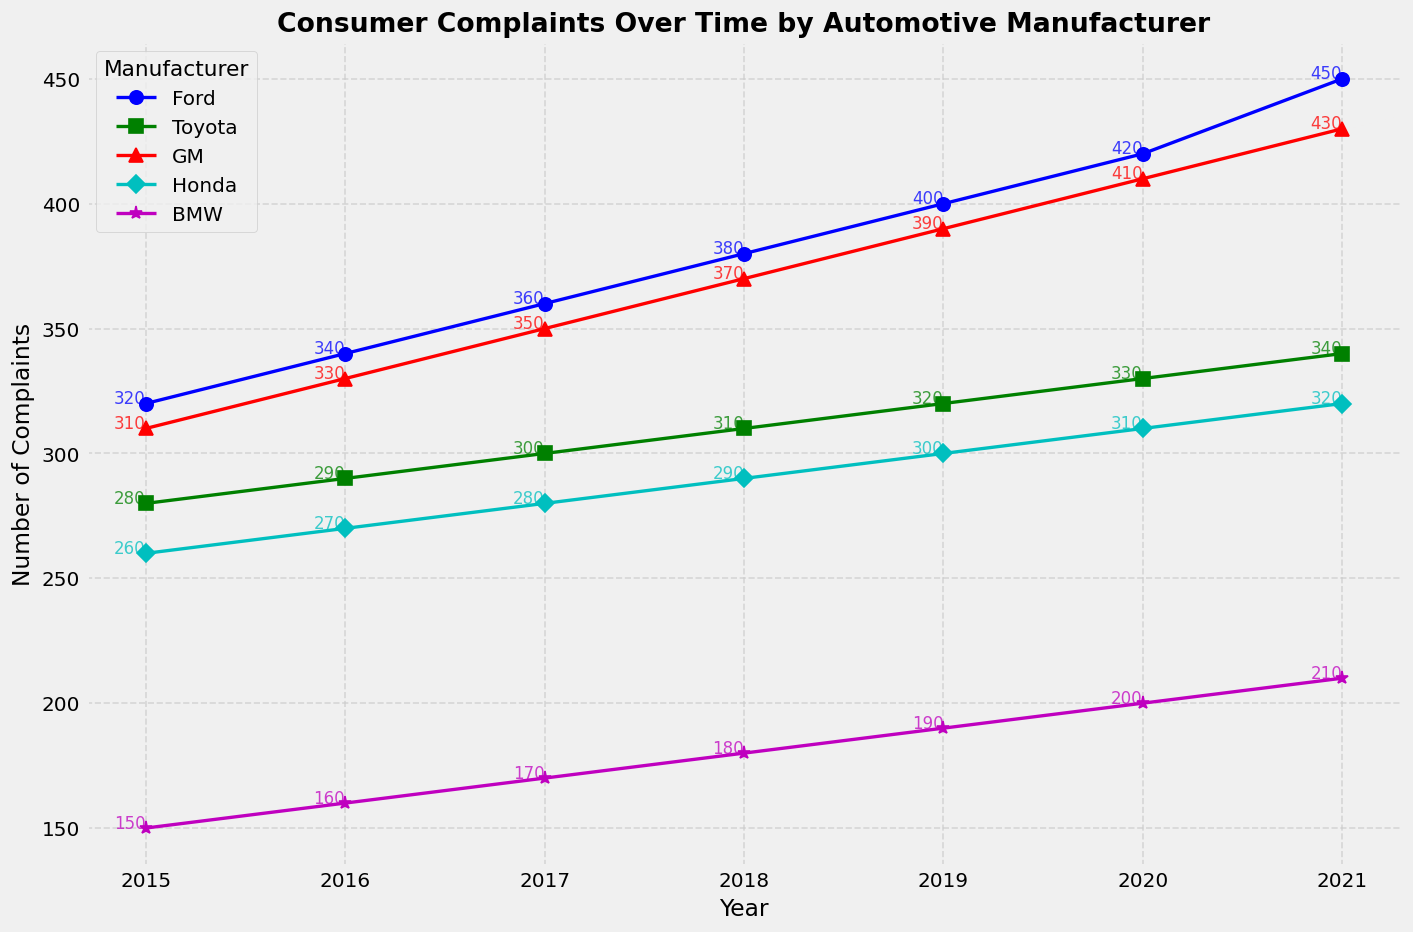Is the number of complaints for Ford consistently increasing each year? From the plot, observe the trendline of the blue line with circle markers representing Ford's complaints over the years 2015 to 2021. The line shows an upward slope each year.
Answer: Yes In which year did Toyota receive the highest number of complaints? From the annotations and the green line with square markers representing Toyota, the highest point on this line is in 2021 where Toyota received 340 complaints.
Answer: 2021 Which manufacturer had the least number of complaints in 2017? Look at the lines and annotations at the 2017 mark. The purple line with star markers representing BMW shows the lowest annotated value for 2017 with 170 complaints.
Answer: BMW Did GM have more complaints than Honda in 2019? Compare the annotations for GM (red line with triangle markers) and Honda (cyan line with diamond markers) at the 2019 mark. GM had 390 complaints while Honda had 300.
Answer: Yes What is the average number of complaints Ford received from 2015 to 2017? Sum the annotations of Ford (blue line) for the years 2015, 2016, and 2017: (320 + 340 + 360) = 1020. Divide by 3 to get the average: 1020 / 3 = 340.
Answer: 340 How does the trend of complaints for BMW compare to that of Honda over the years? Observe the overall trends for BMW (purple line) and Honda (cyan line). Both lines show consistent increases, but BMW's increase is less steep compared to Honda's. This indicates BMW has fewer complaints increasing at a lower rate than Honda.
Answer: BMW's increase is less steep than Honda's Which manufacturer had the most significant increase in complaints from 2018 to 2020? Examine the difference in the annotated complaints for each manufacturer between 2018 and 2020. Ford's complaints increased from 380 to 420, an increase of 40, which is the largest compared to other manufacturers.
Answer: Ford Are there any years where the number of complaints did not change significantly for any manufacturer? Compare the complaints year-over-year for each manufacturer. In 2015 and 2016, Toyota's complaints only increased from 280 to 290, a small difference compared to other jumps.
Answer: 2015-2016 for Toyota 